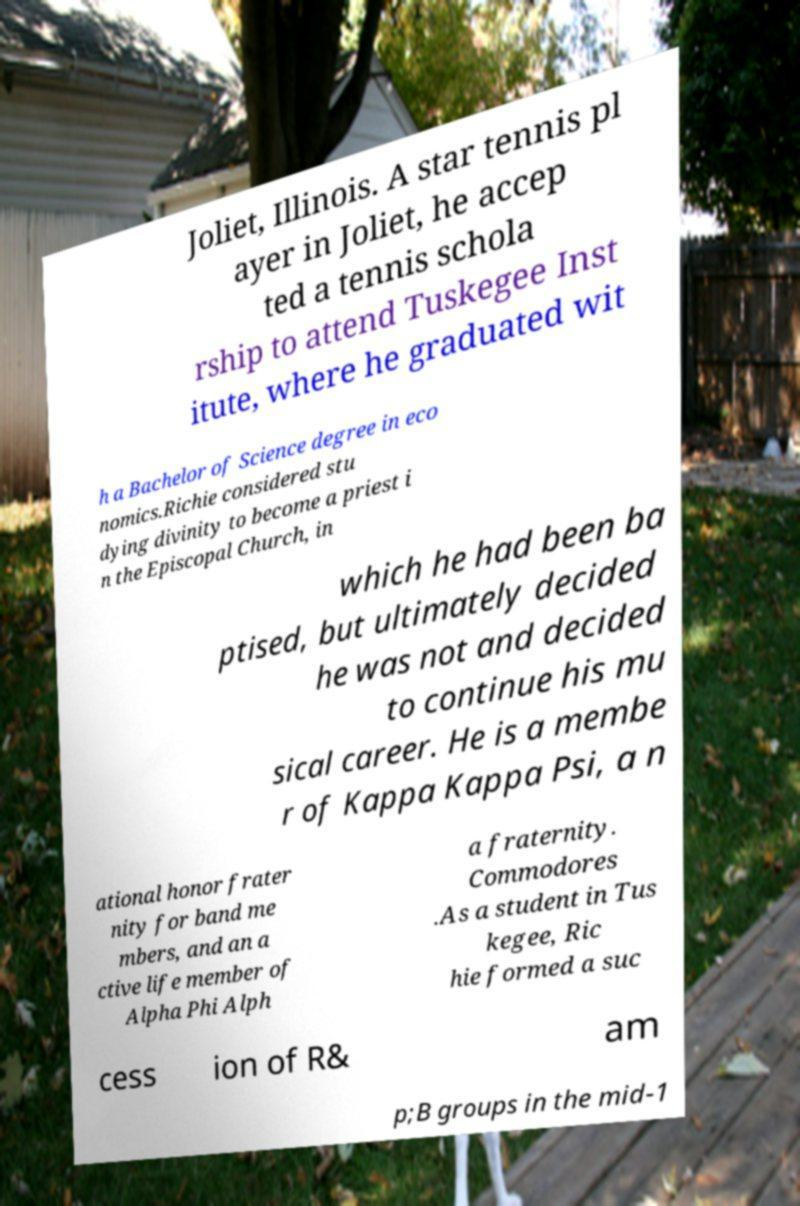Please identify and transcribe the text found in this image. Joliet, Illinois. A star tennis pl ayer in Joliet, he accep ted a tennis schola rship to attend Tuskegee Inst itute, where he graduated wit h a Bachelor of Science degree in eco nomics.Richie considered stu dying divinity to become a priest i n the Episcopal Church, in which he had been ba ptised, but ultimately decided he was not and decided to continue his mu sical career. He is a membe r of Kappa Kappa Psi, a n ational honor frater nity for band me mbers, and an a ctive life member of Alpha Phi Alph a fraternity. Commodores .As a student in Tus kegee, Ric hie formed a suc cess ion of R& am p;B groups in the mid-1 